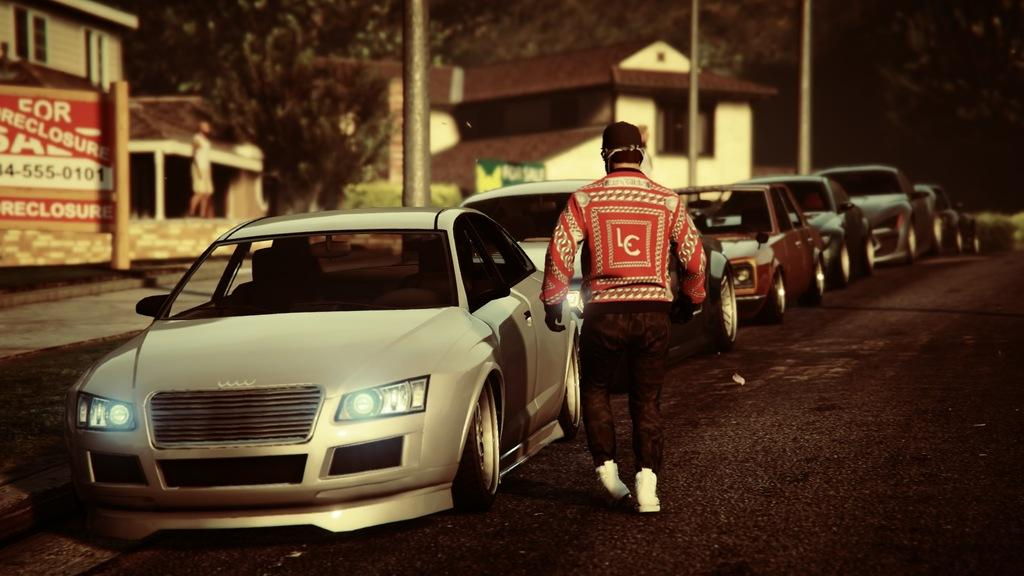Where was the image taken? The image was taken outside. What can be seen in the middle of the image? There are cars and a person in the middle of the image. What is the person in the image doing? The person is walking. What can be seen at the top of the image? There are trees at the top of the image. What type of structures are visible in the middle of the image? There are buildings in the middle of the image. What type of silver throne can be seen in the image? There is no silver throne present in the image. Is there a letter being delivered by the person in the image? There is no letter or delivery mentioned in the image; the person is simply walking. 